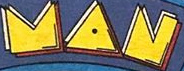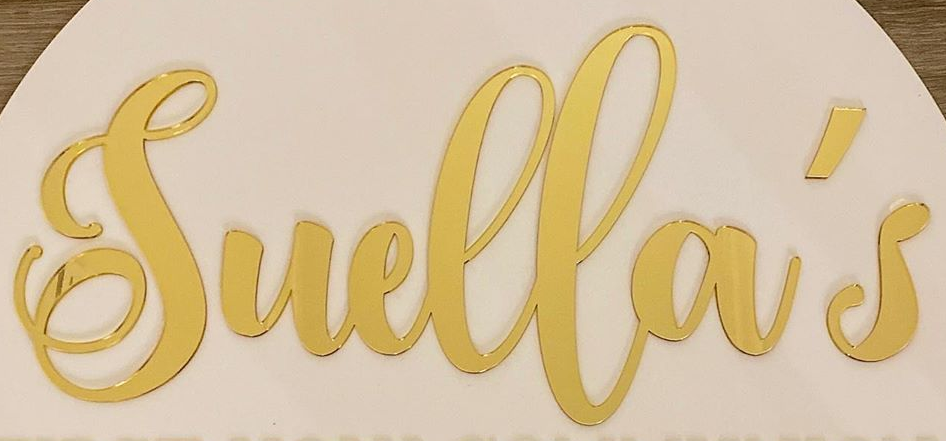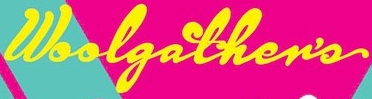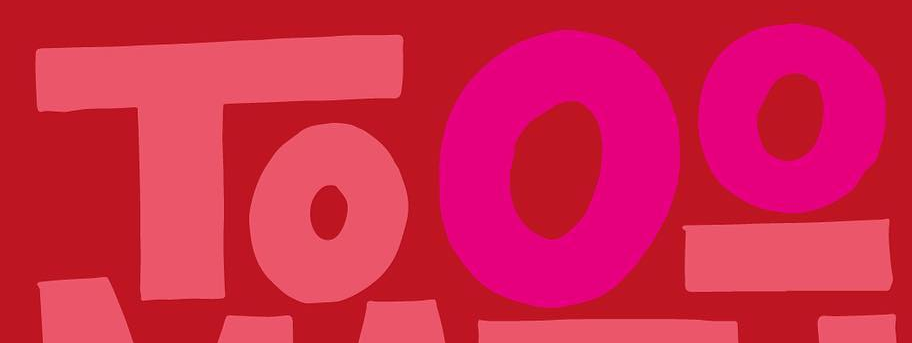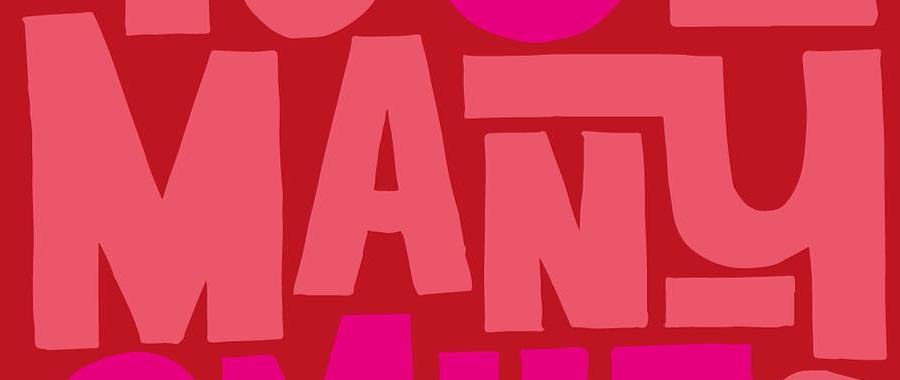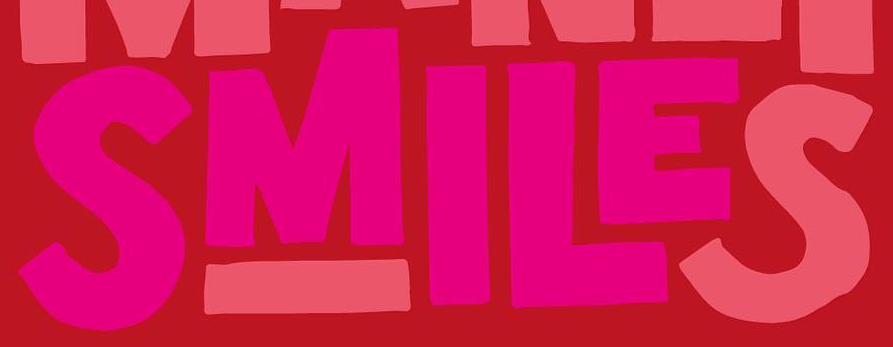What words are shown in these images in order, separated by a semicolon? MAN; Suella's; Woolgather's; Tooo; MANY; SMILES 